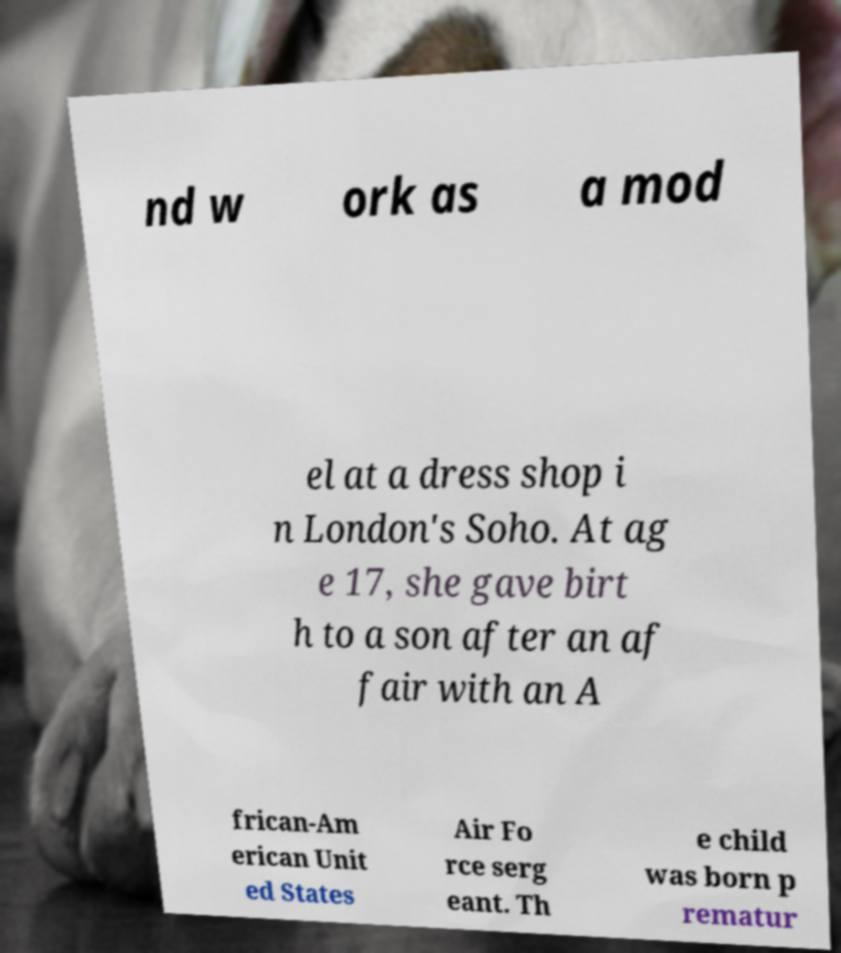I need the written content from this picture converted into text. Can you do that? nd w ork as a mod el at a dress shop i n London's Soho. At ag e 17, she gave birt h to a son after an af fair with an A frican-Am erican Unit ed States Air Fo rce serg eant. Th e child was born p rematur 